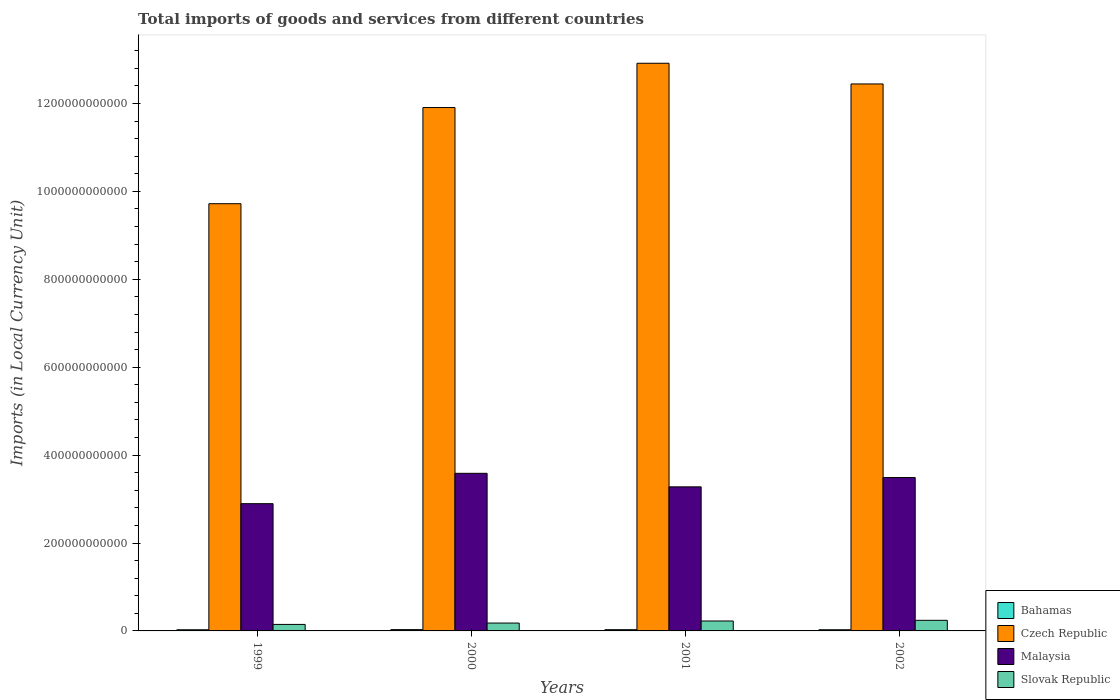How many groups of bars are there?
Offer a very short reply. 4. What is the label of the 3rd group of bars from the left?
Keep it short and to the point. 2001. In how many cases, is the number of bars for a given year not equal to the number of legend labels?
Provide a succinct answer. 0. What is the Amount of goods and services imports in Malaysia in 2001?
Provide a succinct answer. 3.28e+11. Across all years, what is the maximum Amount of goods and services imports in Bahamas?
Provide a succinct answer. 2.96e+09. Across all years, what is the minimum Amount of goods and services imports in Bahamas?
Keep it short and to the point. 2.66e+09. In which year was the Amount of goods and services imports in Malaysia minimum?
Your answer should be very brief. 1999. What is the total Amount of goods and services imports in Slovak Republic in the graph?
Give a very brief answer. 7.94e+1. What is the difference between the Amount of goods and services imports in Malaysia in 2001 and that in 2002?
Offer a terse response. -2.12e+1. What is the difference between the Amount of goods and services imports in Malaysia in 2001 and the Amount of goods and services imports in Bahamas in 2002?
Offer a terse response. 3.25e+11. What is the average Amount of goods and services imports in Bahamas per year?
Provide a short and direct response. 2.78e+09. In the year 1999, what is the difference between the Amount of goods and services imports in Slovak Republic and Amount of goods and services imports in Malaysia?
Offer a very short reply. -2.75e+11. What is the ratio of the Amount of goods and services imports in Slovak Republic in 2001 to that in 2002?
Your answer should be very brief. 0.94. Is the Amount of goods and services imports in Slovak Republic in 2000 less than that in 2001?
Provide a succinct answer. Yes. Is the difference between the Amount of goods and services imports in Slovak Republic in 1999 and 2000 greater than the difference between the Amount of goods and services imports in Malaysia in 1999 and 2000?
Your answer should be very brief. Yes. What is the difference between the highest and the second highest Amount of goods and services imports in Slovak Republic?
Give a very brief answer. 1.54e+09. What is the difference between the highest and the lowest Amount of goods and services imports in Malaysia?
Your answer should be very brief. 6.90e+1. In how many years, is the Amount of goods and services imports in Czech Republic greater than the average Amount of goods and services imports in Czech Republic taken over all years?
Provide a succinct answer. 3. What does the 2nd bar from the left in 1999 represents?
Make the answer very short. Czech Republic. What does the 2nd bar from the right in 1999 represents?
Your response must be concise. Malaysia. How many bars are there?
Your answer should be compact. 16. What is the difference between two consecutive major ticks on the Y-axis?
Ensure brevity in your answer.  2.00e+11. Does the graph contain grids?
Your response must be concise. No. How many legend labels are there?
Make the answer very short. 4. How are the legend labels stacked?
Your answer should be compact. Vertical. What is the title of the graph?
Your answer should be very brief. Total imports of goods and services from different countries. Does "Dominica" appear as one of the legend labels in the graph?
Ensure brevity in your answer.  No. What is the label or title of the Y-axis?
Ensure brevity in your answer.  Imports (in Local Currency Unit). What is the Imports (in Local Currency Unit) in Bahamas in 1999?
Your answer should be compact. 2.66e+09. What is the Imports (in Local Currency Unit) in Czech Republic in 1999?
Provide a succinct answer. 9.72e+11. What is the Imports (in Local Currency Unit) of Malaysia in 1999?
Offer a very short reply. 2.90e+11. What is the Imports (in Local Currency Unit) of Slovak Republic in 1999?
Ensure brevity in your answer.  1.48e+1. What is the Imports (in Local Currency Unit) of Bahamas in 2000?
Your answer should be compact. 2.96e+09. What is the Imports (in Local Currency Unit) in Czech Republic in 2000?
Your answer should be compact. 1.19e+12. What is the Imports (in Local Currency Unit) of Malaysia in 2000?
Offer a terse response. 3.59e+11. What is the Imports (in Local Currency Unit) in Slovak Republic in 2000?
Offer a terse response. 1.79e+1. What is the Imports (in Local Currency Unit) of Bahamas in 2001?
Provide a short and direct response. 2.82e+09. What is the Imports (in Local Currency Unit) in Czech Republic in 2001?
Provide a short and direct response. 1.29e+12. What is the Imports (in Local Currency Unit) of Malaysia in 2001?
Offer a very short reply. 3.28e+11. What is the Imports (in Local Currency Unit) in Slovak Republic in 2001?
Your answer should be very brief. 2.26e+1. What is the Imports (in Local Currency Unit) in Bahamas in 2002?
Your response must be concise. 2.67e+09. What is the Imports (in Local Currency Unit) in Czech Republic in 2002?
Ensure brevity in your answer.  1.24e+12. What is the Imports (in Local Currency Unit) of Malaysia in 2002?
Ensure brevity in your answer.  3.49e+11. What is the Imports (in Local Currency Unit) in Slovak Republic in 2002?
Your answer should be compact. 2.41e+1. Across all years, what is the maximum Imports (in Local Currency Unit) in Bahamas?
Provide a succinct answer. 2.96e+09. Across all years, what is the maximum Imports (in Local Currency Unit) in Czech Republic?
Offer a terse response. 1.29e+12. Across all years, what is the maximum Imports (in Local Currency Unit) in Malaysia?
Your response must be concise. 3.59e+11. Across all years, what is the maximum Imports (in Local Currency Unit) of Slovak Republic?
Keep it short and to the point. 2.41e+1. Across all years, what is the minimum Imports (in Local Currency Unit) in Bahamas?
Offer a terse response. 2.66e+09. Across all years, what is the minimum Imports (in Local Currency Unit) in Czech Republic?
Ensure brevity in your answer.  9.72e+11. Across all years, what is the minimum Imports (in Local Currency Unit) of Malaysia?
Provide a succinct answer. 2.90e+11. Across all years, what is the minimum Imports (in Local Currency Unit) of Slovak Republic?
Your response must be concise. 1.48e+1. What is the total Imports (in Local Currency Unit) in Bahamas in the graph?
Make the answer very short. 1.11e+1. What is the total Imports (in Local Currency Unit) in Czech Republic in the graph?
Provide a succinct answer. 4.70e+12. What is the total Imports (in Local Currency Unit) in Malaysia in the graph?
Offer a terse response. 1.32e+12. What is the total Imports (in Local Currency Unit) in Slovak Republic in the graph?
Your response must be concise. 7.94e+1. What is the difference between the Imports (in Local Currency Unit) of Bahamas in 1999 and that in 2000?
Make the answer very short. -3.04e+08. What is the difference between the Imports (in Local Currency Unit) of Czech Republic in 1999 and that in 2000?
Make the answer very short. -2.19e+11. What is the difference between the Imports (in Local Currency Unit) in Malaysia in 1999 and that in 2000?
Give a very brief answer. -6.90e+1. What is the difference between the Imports (in Local Currency Unit) of Slovak Republic in 1999 and that in 2000?
Your response must be concise. -3.09e+09. What is the difference between the Imports (in Local Currency Unit) of Bahamas in 1999 and that in 2001?
Keep it short and to the point. -1.59e+08. What is the difference between the Imports (in Local Currency Unit) in Czech Republic in 1999 and that in 2001?
Your response must be concise. -3.20e+11. What is the difference between the Imports (in Local Currency Unit) in Malaysia in 1999 and that in 2001?
Your response must be concise. -3.83e+1. What is the difference between the Imports (in Local Currency Unit) in Slovak Republic in 1999 and that in 2001?
Provide a short and direct response. -7.77e+09. What is the difference between the Imports (in Local Currency Unit) of Bahamas in 1999 and that in 2002?
Provide a succinct answer. -1.16e+07. What is the difference between the Imports (in Local Currency Unit) in Czech Republic in 1999 and that in 2002?
Keep it short and to the point. -2.72e+11. What is the difference between the Imports (in Local Currency Unit) of Malaysia in 1999 and that in 2002?
Offer a very short reply. -5.94e+1. What is the difference between the Imports (in Local Currency Unit) of Slovak Republic in 1999 and that in 2002?
Provide a short and direct response. -9.32e+09. What is the difference between the Imports (in Local Currency Unit) in Bahamas in 2000 and that in 2001?
Offer a very short reply. 1.44e+08. What is the difference between the Imports (in Local Currency Unit) of Czech Republic in 2000 and that in 2001?
Offer a terse response. -1.01e+11. What is the difference between the Imports (in Local Currency Unit) in Malaysia in 2000 and that in 2001?
Ensure brevity in your answer.  3.08e+1. What is the difference between the Imports (in Local Currency Unit) of Slovak Republic in 2000 and that in 2001?
Provide a short and direct response. -4.69e+09. What is the difference between the Imports (in Local Currency Unit) in Bahamas in 2000 and that in 2002?
Ensure brevity in your answer.  2.92e+08. What is the difference between the Imports (in Local Currency Unit) in Czech Republic in 2000 and that in 2002?
Give a very brief answer. -5.37e+1. What is the difference between the Imports (in Local Currency Unit) in Malaysia in 2000 and that in 2002?
Provide a succinct answer. 9.61e+09. What is the difference between the Imports (in Local Currency Unit) of Slovak Republic in 2000 and that in 2002?
Make the answer very short. -6.23e+09. What is the difference between the Imports (in Local Currency Unit) of Bahamas in 2001 and that in 2002?
Your response must be concise. 1.48e+08. What is the difference between the Imports (in Local Currency Unit) of Czech Republic in 2001 and that in 2002?
Your answer should be compact. 4.71e+1. What is the difference between the Imports (in Local Currency Unit) of Malaysia in 2001 and that in 2002?
Provide a succinct answer. -2.12e+1. What is the difference between the Imports (in Local Currency Unit) in Slovak Republic in 2001 and that in 2002?
Your answer should be compact. -1.54e+09. What is the difference between the Imports (in Local Currency Unit) in Bahamas in 1999 and the Imports (in Local Currency Unit) in Czech Republic in 2000?
Provide a succinct answer. -1.19e+12. What is the difference between the Imports (in Local Currency Unit) of Bahamas in 1999 and the Imports (in Local Currency Unit) of Malaysia in 2000?
Offer a terse response. -3.56e+11. What is the difference between the Imports (in Local Currency Unit) in Bahamas in 1999 and the Imports (in Local Currency Unit) in Slovak Republic in 2000?
Provide a succinct answer. -1.52e+1. What is the difference between the Imports (in Local Currency Unit) of Czech Republic in 1999 and the Imports (in Local Currency Unit) of Malaysia in 2000?
Offer a terse response. 6.13e+11. What is the difference between the Imports (in Local Currency Unit) of Czech Republic in 1999 and the Imports (in Local Currency Unit) of Slovak Republic in 2000?
Your answer should be very brief. 9.54e+11. What is the difference between the Imports (in Local Currency Unit) of Malaysia in 1999 and the Imports (in Local Currency Unit) of Slovak Republic in 2000?
Your response must be concise. 2.72e+11. What is the difference between the Imports (in Local Currency Unit) in Bahamas in 1999 and the Imports (in Local Currency Unit) in Czech Republic in 2001?
Your response must be concise. -1.29e+12. What is the difference between the Imports (in Local Currency Unit) in Bahamas in 1999 and the Imports (in Local Currency Unit) in Malaysia in 2001?
Provide a short and direct response. -3.25e+11. What is the difference between the Imports (in Local Currency Unit) of Bahamas in 1999 and the Imports (in Local Currency Unit) of Slovak Republic in 2001?
Provide a succinct answer. -1.99e+1. What is the difference between the Imports (in Local Currency Unit) of Czech Republic in 1999 and the Imports (in Local Currency Unit) of Malaysia in 2001?
Offer a terse response. 6.44e+11. What is the difference between the Imports (in Local Currency Unit) in Czech Republic in 1999 and the Imports (in Local Currency Unit) in Slovak Republic in 2001?
Give a very brief answer. 9.49e+11. What is the difference between the Imports (in Local Currency Unit) in Malaysia in 1999 and the Imports (in Local Currency Unit) in Slovak Republic in 2001?
Provide a succinct answer. 2.67e+11. What is the difference between the Imports (in Local Currency Unit) of Bahamas in 1999 and the Imports (in Local Currency Unit) of Czech Republic in 2002?
Your answer should be very brief. -1.24e+12. What is the difference between the Imports (in Local Currency Unit) in Bahamas in 1999 and the Imports (in Local Currency Unit) in Malaysia in 2002?
Your response must be concise. -3.46e+11. What is the difference between the Imports (in Local Currency Unit) in Bahamas in 1999 and the Imports (in Local Currency Unit) in Slovak Republic in 2002?
Make the answer very short. -2.15e+1. What is the difference between the Imports (in Local Currency Unit) of Czech Republic in 1999 and the Imports (in Local Currency Unit) of Malaysia in 2002?
Your answer should be compact. 6.23e+11. What is the difference between the Imports (in Local Currency Unit) of Czech Republic in 1999 and the Imports (in Local Currency Unit) of Slovak Republic in 2002?
Provide a succinct answer. 9.48e+11. What is the difference between the Imports (in Local Currency Unit) in Malaysia in 1999 and the Imports (in Local Currency Unit) in Slovak Republic in 2002?
Keep it short and to the point. 2.65e+11. What is the difference between the Imports (in Local Currency Unit) in Bahamas in 2000 and the Imports (in Local Currency Unit) in Czech Republic in 2001?
Provide a short and direct response. -1.29e+12. What is the difference between the Imports (in Local Currency Unit) of Bahamas in 2000 and the Imports (in Local Currency Unit) of Malaysia in 2001?
Give a very brief answer. -3.25e+11. What is the difference between the Imports (in Local Currency Unit) of Bahamas in 2000 and the Imports (in Local Currency Unit) of Slovak Republic in 2001?
Ensure brevity in your answer.  -1.96e+1. What is the difference between the Imports (in Local Currency Unit) in Czech Republic in 2000 and the Imports (in Local Currency Unit) in Malaysia in 2001?
Offer a terse response. 8.63e+11. What is the difference between the Imports (in Local Currency Unit) in Czech Republic in 2000 and the Imports (in Local Currency Unit) in Slovak Republic in 2001?
Ensure brevity in your answer.  1.17e+12. What is the difference between the Imports (in Local Currency Unit) in Malaysia in 2000 and the Imports (in Local Currency Unit) in Slovak Republic in 2001?
Your answer should be compact. 3.36e+11. What is the difference between the Imports (in Local Currency Unit) in Bahamas in 2000 and the Imports (in Local Currency Unit) in Czech Republic in 2002?
Provide a succinct answer. -1.24e+12. What is the difference between the Imports (in Local Currency Unit) of Bahamas in 2000 and the Imports (in Local Currency Unit) of Malaysia in 2002?
Your answer should be very brief. -3.46e+11. What is the difference between the Imports (in Local Currency Unit) in Bahamas in 2000 and the Imports (in Local Currency Unit) in Slovak Republic in 2002?
Your response must be concise. -2.12e+1. What is the difference between the Imports (in Local Currency Unit) of Czech Republic in 2000 and the Imports (in Local Currency Unit) of Malaysia in 2002?
Your answer should be compact. 8.42e+11. What is the difference between the Imports (in Local Currency Unit) of Czech Republic in 2000 and the Imports (in Local Currency Unit) of Slovak Republic in 2002?
Keep it short and to the point. 1.17e+12. What is the difference between the Imports (in Local Currency Unit) in Malaysia in 2000 and the Imports (in Local Currency Unit) in Slovak Republic in 2002?
Ensure brevity in your answer.  3.34e+11. What is the difference between the Imports (in Local Currency Unit) of Bahamas in 2001 and the Imports (in Local Currency Unit) of Czech Republic in 2002?
Provide a succinct answer. -1.24e+12. What is the difference between the Imports (in Local Currency Unit) of Bahamas in 2001 and the Imports (in Local Currency Unit) of Malaysia in 2002?
Provide a short and direct response. -3.46e+11. What is the difference between the Imports (in Local Currency Unit) of Bahamas in 2001 and the Imports (in Local Currency Unit) of Slovak Republic in 2002?
Provide a succinct answer. -2.13e+1. What is the difference between the Imports (in Local Currency Unit) of Czech Republic in 2001 and the Imports (in Local Currency Unit) of Malaysia in 2002?
Offer a terse response. 9.42e+11. What is the difference between the Imports (in Local Currency Unit) in Czech Republic in 2001 and the Imports (in Local Currency Unit) in Slovak Republic in 2002?
Your answer should be compact. 1.27e+12. What is the difference between the Imports (in Local Currency Unit) in Malaysia in 2001 and the Imports (in Local Currency Unit) in Slovak Republic in 2002?
Give a very brief answer. 3.04e+11. What is the average Imports (in Local Currency Unit) in Bahamas per year?
Make the answer very short. 2.78e+09. What is the average Imports (in Local Currency Unit) in Czech Republic per year?
Offer a very short reply. 1.17e+12. What is the average Imports (in Local Currency Unit) of Malaysia per year?
Ensure brevity in your answer.  3.31e+11. What is the average Imports (in Local Currency Unit) in Slovak Republic per year?
Your response must be concise. 1.99e+1. In the year 1999, what is the difference between the Imports (in Local Currency Unit) in Bahamas and Imports (in Local Currency Unit) in Czech Republic?
Offer a very short reply. -9.69e+11. In the year 1999, what is the difference between the Imports (in Local Currency Unit) of Bahamas and Imports (in Local Currency Unit) of Malaysia?
Ensure brevity in your answer.  -2.87e+11. In the year 1999, what is the difference between the Imports (in Local Currency Unit) of Bahamas and Imports (in Local Currency Unit) of Slovak Republic?
Provide a succinct answer. -1.21e+1. In the year 1999, what is the difference between the Imports (in Local Currency Unit) of Czech Republic and Imports (in Local Currency Unit) of Malaysia?
Provide a succinct answer. 6.82e+11. In the year 1999, what is the difference between the Imports (in Local Currency Unit) of Czech Republic and Imports (in Local Currency Unit) of Slovak Republic?
Ensure brevity in your answer.  9.57e+11. In the year 1999, what is the difference between the Imports (in Local Currency Unit) of Malaysia and Imports (in Local Currency Unit) of Slovak Republic?
Your response must be concise. 2.75e+11. In the year 2000, what is the difference between the Imports (in Local Currency Unit) in Bahamas and Imports (in Local Currency Unit) in Czech Republic?
Give a very brief answer. -1.19e+12. In the year 2000, what is the difference between the Imports (in Local Currency Unit) in Bahamas and Imports (in Local Currency Unit) in Malaysia?
Provide a succinct answer. -3.56e+11. In the year 2000, what is the difference between the Imports (in Local Currency Unit) of Bahamas and Imports (in Local Currency Unit) of Slovak Republic?
Offer a terse response. -1.49e+1. In the year 2000, what is the difference between the Imports (in Local Currency Unit) in Czech Republic and Imports (in Local Currency Unit) in Malaysia?
Provide a succinct answer. 8.32e+11. In the year 2000, what is the difference between the Imports (in Local Currency Unit) of Czech Republic and Imports (in Local Currency Unit) of Slovak Republic?
Keep it short and to the point. 1.17e+12. In the year 2000, what is the difference between the Imports (in Local Currency Unit) in Malaysia and Imports (in Local Currency Unit) in Slovak Republic?
Your response must be concise. 3.41e+11. In the year 2001, what is the difference between the Imports (in Local Currency Unit) of Bahamas and Imports (in Local Currency Unit) of Czech Republic?
Provide a succinct answer. -1.29e+12. In the year 2001, what is the difference between the Imports (in Local Currency Unit) of Bahamas and Imports (in Local Currency Unit) of Malaysia?
Provide a short and direct response. -3.25e+11. In the year 2001, what is the difference between the Imports (in Local Currency Unit) of Bahamas and Imports (in Local Currency Unit) of Slovak Republic?
Your answer should be very brief. -1.98e+1. In the year 2001, what is the difference between the Imports (in Local Currency Unit) of Czech Republic and Imports (in Local Currency Unit) of Malaysia?
Offer a terse response. 9.64e+11. In the year 2001, what is the difference between the Imports (in Local Currency Unit) in Czech Republic and Imports (in Local Currency Unit) in Slovak Republic?
Make the answer very short. 1.27e+12. In the year 2001, what is the difference between the Imports (in Local Currency Unit) of Malaysia and Imports (in Local Currency Unit) of Slovak Republic?
Offer a terse response. 3.05e+11. In the year 2002, what is the difference between the Imports (in Local Currency Unit) of Bahamas and Imports (in Local Currency Unit) of Czech Republic?
Keep it short and to the point. -1.24e+12. In the year 2002, what is the difference between the Imports (in Local Currency Unit) of Bahamas and Imports (in Local Currency Unit) of Malaysia?
Provide a succinct answer. -3.46e+11. In the year 2002, what is the difference between the Imports (in Local Currency Unit) of Bahamas and Imports (in Local Currency Unit) of Slovak Republic?
Your response must be concise. -2.15e+1. In the year 2002, what is the difference between the Imports (in Local Currency Unit) in Czech Republic and Imports (in Local Currency Unit) in Malaysia?
Make the answer very short. 8.95e+11. In the year 2002, what is the difference between the Imports (in Local Currency Unit) in Czech Republic and Imports (in Local Currency Unit) in Slovak Republic?
Keep it short and to the point. 1.22e+12. In the year 2002, what is the difference between the Imports (in Local Currency Unit) of Malaysia and Imports (in Local Currency Unit) of Slovak Republic?
Provide a succinct answer. 3.25e+11. What is the ratio of the Imports (in Local Currency Unit) of Bahamas in 1999 to that in 2000?
Provide a short and direct response. 0.9. What is the ratio of the Imports (in Local Currency Unit) in Czech Republic in 1999 to that in 2000?
Your answer should be very brief. 0.82. What is the ratio of the Imports (in Local Currency Unit) in Malaysia in 1999 to that in 2000?
Provide a succinct answer. 0.81. What is the ratio of the Imports (in Local Currency Unit) in Slovak Republic in 1999 to that in 2000?
Offer a terse response. 0.83. What is the ratio of the Imports (in Local Currency Unit) in Bahamas in 1999 to that in 2001?
Provide a succinct answer. 0.94. What is the ratio of the Imports (in Local Currency Unit) of Czech Republic in 1999 to that in 2001?
Provide a succinct answer. 0.75. What is the ratio of the Imports (in Local Currency Unit) of Malaysia in 1999 to that in 2001?
Your answer should be compact. 0.88. What is the ratio of the Imports (in Local Currency Unit) in Slovak Republic in 1999 to that in 2001?
Make the answer very short. 0.66. What is the ratio of the Imports (in Local Currency Unit) in Czech Republic in 1999 to that in 2002?
Your answer should be compact. 0.78. What is the ratio of the Imports (in Local Currency Unit) of Malaysia in 1999 to that in 2002?
Offer a very short reply. 0.83. What is the ratio of the Imports (in Local Currency Unit) of Slovak Republic in 1999 to that in 2002?
Offer a terse response. 0.61. What is the ratio of the Imports (in Local Currency Unit) in Bahamas in 2000 to that in 2001?
Provide a succinct answer. 1.05. What is the ratio of the Imports (in Local Currency Unit) of Czech Republic in 2000 to that in 2001?
Offer a terse response. 0.92. What is the ratio of the Imports (in Local Currency Unit) in Malaysia in 2000 to that in 2001?
Offer a terse response. 1.09. What is the ratio of the Imports (in Local Currency Unit) of Slovak Republic in 2000 to that in 2001?
Keep it short and to the point. 0.79. What is the ratio of the Imports (in Local Currency Unit) of Bahamas in 2000 to that in 2002?
Ensure brevity in your answer.  1.11. What is the ratio of the Imports (in Local Currency Unit) in Czech Republic in 2000 to that in 2002?
Your response must be concise. 0.96. What is the ratio of the Imports (in Local Currency Unit) in Malaysia in 2000 to that in 2002?
Provide a short and direct response. 1.03. What is the ratio of the Imports (in Local Currency Unit) in Slovak Republic in 2000 to that in 2002?
Your answer should be compact. 0.74. What is the ratio of the Imports (in Local Currency Unit) of Bahamas in 2001 to that in 2002?
Ensure brevity in your answer.  1.06. What is the ratio of the Imports (in Local Currency Unit) of Czech Republic in 2001 to that in 2002?
Offer a very short reply. 1.04. What is the ratio of the Imports (in Local Currency Unit) in Malaysia in 2001 to that in 2002?
Your response must be concise. 0.94. What is the ratio of the Imports (in Local Currency Unit) of Slovak Republic in 2001 to that in 2002?
Your answer should be very brief. 0.94. What is the difference between the highest and the second highest Imports (in Local Currency Unit) in Bahamas?
Make the answer very short. 1.44e+08. What is the difference between the highest and the second highest Imports (in Local Currency Unit) in Czech Republic?
Provide a succinct answer. 4.71e+1. What is the difference between the highest and the second highest Imports (in Local Currency Unit) in Malaysia?
Give a very brief answer. 9.61e+09. What is the difference between the highest and the second highest Imports (in Local Currency Unit) in Slovak Republic?
Provide a short and direct response. 1.54e+09. What is the difference between the highest and the lowest Imports (in Local Currency Unit) in Bahamas?
Your answer should be compact. 3.04e+08. What is the difference between the highest and the lowest Imports (in Local Currency Unit) of Czech Republic?
Offer a terse response. 3.20e+11. What is the difference between the highest and the lowest Imports (in Local Currency Unit) in Malaysia?
Ensure brevity in your answer.  6.90e+1. What is the difference between the highest and the lowest Imports (in Local Currency Unit) in Slovak Republic?
Keep it short and to the point. 9.32e+09. 